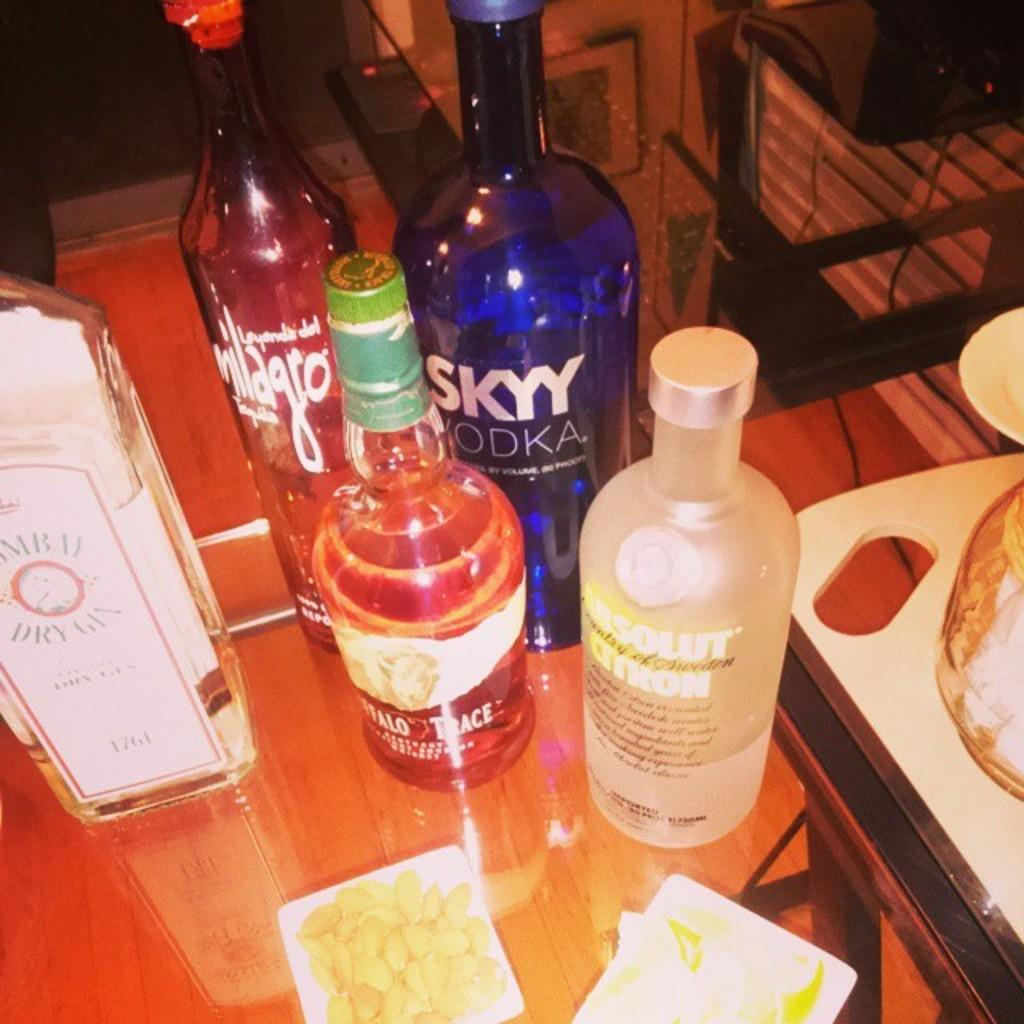How many wine bottles are visible in the image? There are five wine bottles in the image. What else can be seen on the table in the image? There is food on a table in the image. Are there any fairies present in the image, laughing and working as a team? No, there are no fairies present in the image, and the image does not depict any laughter or teamwork. 